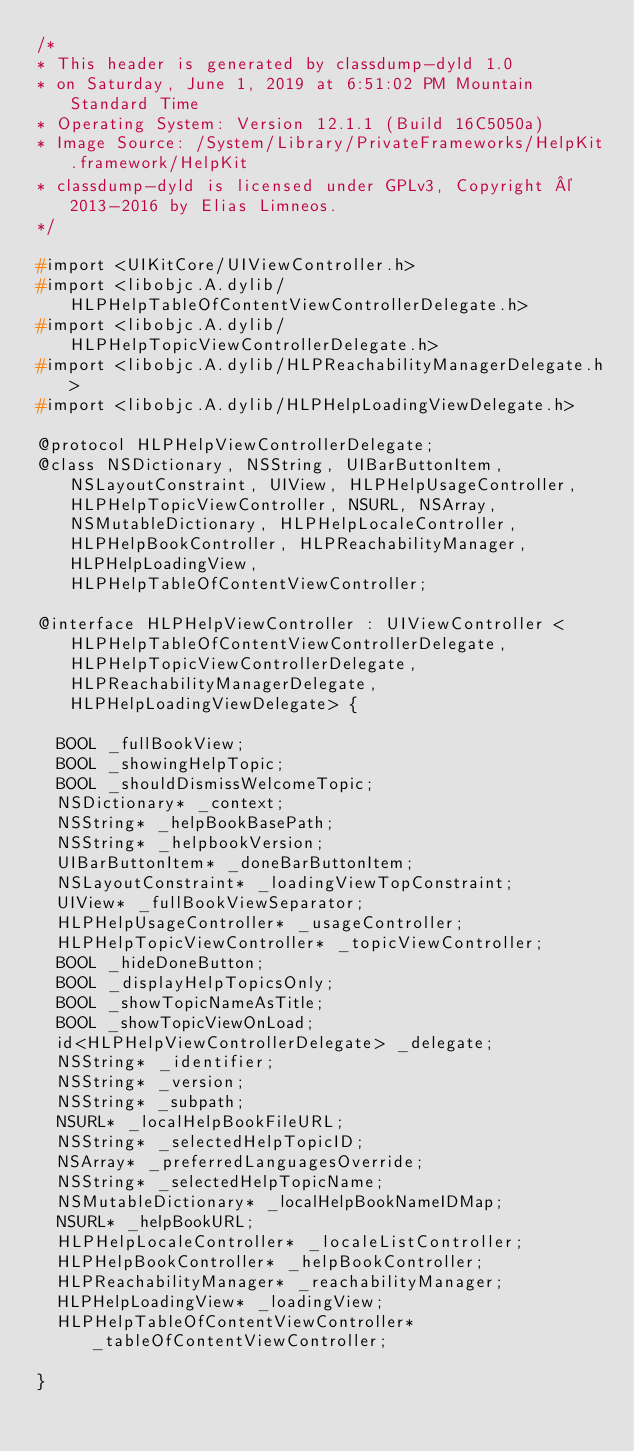Convert code to text. <code><loc_0><loc_0><loc_500><loc_500><_C_>/*
* This header is generated by classdump-dyld 1.0
* on Saturday, June 1, 2019 at 6:51:02 PM Mountain Standard Time
* Operating System: Version 12.1.1 (Build 16C5050a)
* Image Source: /System/Library/PrivateFrameworks/HelpKit.framework/HelpKit
* classdump-dyld is licensed under GPLv3, Copyright © 2013-2016 by Elias Limneos.
*/

#import <UIKitCore/UIViewController.h>
#import <libobjc.A.dylib/HLPHelpTableOfContentViewControllerDelegate.h>
#import <libobjc.A.dylib/HLPHelpTopicViewControllerDelegate.h>
#import <libobjc.A.dylib/HLPReachabilityManagerDelegate.h>
#import <libobjc.A.dylib/HLPHelpLoadingViewDelegate.h>

@protocol HLPHelpViewControllerDelegate;
@class NSDictionary, NSString, UIBarButtonItem, NSLayoutConstraint, UIView, HLPHelpUsageController, HLPHelpTopicViewController, NSURL, NSArray, NSMutableDictionary, HLPHelpLocaleController, HLPHelpBookController, HLPReachabilityManager, HLPHelpLoadingView, HLPHelpTableOfContentViewController;

@interface HLPHelpViewController : UIViewController <HLPHelpTableOfContentViewControllerDelegate, HLPHelpTopicViewControllerDelegate, HLPReachabilityManagerDelegate, HLPHelpLoadingViewDelegate> {

	BOOL _fullBookView;
	BOOL _showingHelpTopic;
	BOOL _shouldDismissWelcomeTopic;
	NSDictionary* _context;
	NSString* _helpBookBasePath;
	NSString* _helpbookVersion;
	UIBarButtonItem* _doneBarButtonItem;
	NSLayoutConstraint* _loadingViewTopConstraint;
	UIView* _fullBookViewSeparator;
	HLPHelpUsageController* _usageController;
	HLPHelpTopicViewController* _topicViewController;
	BOOL _hideDoneButton;
	BOOL _displayHelpTopicsOnly;
	BOOL _showTopicNameAsTitle;
	BOOL _showTopicViewOnLoad;
	id<HLPHelpViewControllerDelegate> _delegate;
	NSString* _identifier;
	NSString* _version;
	NSString* _subpath;
	NSURL* _localHelpBookFileURL;
	NSString* _selectedHelpTopicID;
	NSArray* _preferredLanguagesOverride;
	NSString* _selectedHelpTopicName;
	NSMutableDictionary* _localHelpBookNameIDMap;
	NSURL* _helpBookURL;
	HLPHelpLocaleController* _localeListController;
	HLPHelpBookController* _helpBookController;
	HLPReachabilityManager* _reachabilityManager;
	HLPHelpLoadingView* _loadingView;
	HLPHelpTableOfContentViewController* _tableOfContentViewController;

}
</code> 